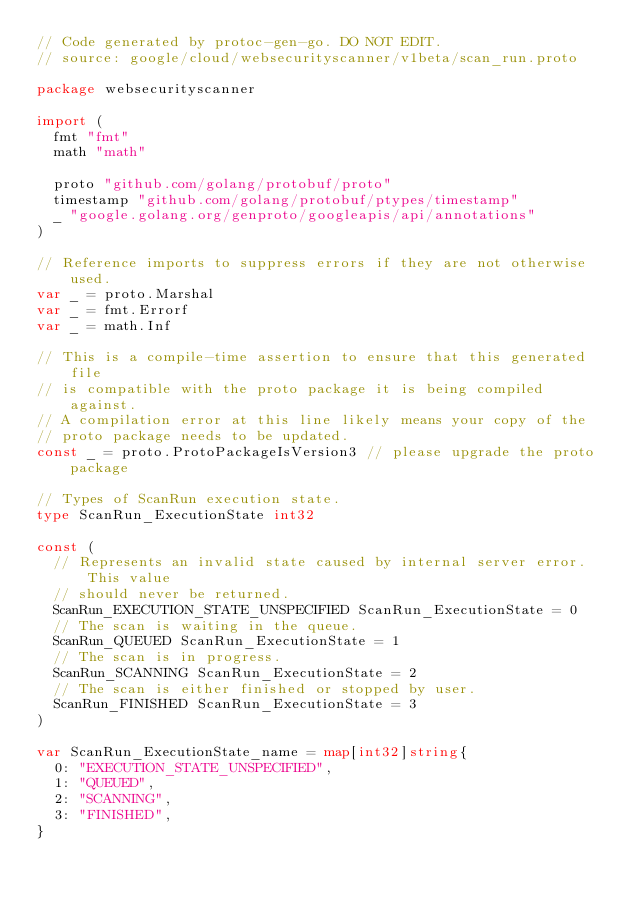<code> <loc_0><loc_0><loc_500><loc_500><_Go_>// Code generated by protoc-gen-go. DO NOT EDIT.
// source: google/cloud/websecurityscanner/v1beta/scan_run.proto

package websecurityscanner

import (
	fmt "fmt"
	math "math"

	proto "github.com/golang/protobuf/proto"
	timestamp "github.com/golang/protobuf/ptypes/timestamp"
	_ "google.golang.org/genproto/googleapis/api/annotations"
)

// Reference imports to suppress errors if they are not otherwise used.
var _ = proto.Marshal
var _ = fmt.Errorf
var _ = math.Inf

// This is a compile-time assertion to ensure that this generated file
// is compatible with the proto package it is being compiled against.
// A compilation error at this line likely means your copy of the
// proto package needs to be updated.
const _ = proto.ProtoPackageIsVersion3 // please upgrade the proto package

// Types of ScanRun execution state.
type ScanRun_ExecutionState int32

const (
	// Represents an invalid state caused by internal server error. This value
	// should never be returned.
	ScanRun_EXECUTION_STATE_UNSPECIFIED ScanRun_ExecutionState = 0
	// The scan is waiting in the queue.
	ScanRun_QUEUED ScanRun_ExecutionState = 1
	// The scan is in progress.
	ScanRun_SCANNING ScanRun_ExecutionState = 2
	// The scan is either finished or stopped by user.
	ScanRun_FINISHED ScanRun_ExecutionState = 3
)

var ScanRun_ExecutionState_name = map[int32]string{
	0: "EXECUTION_STATE_UNSPECIFIED",
	1: "QUEUED",
	2: "SCANNING",
	3: "FINISHED",
}
</code> 